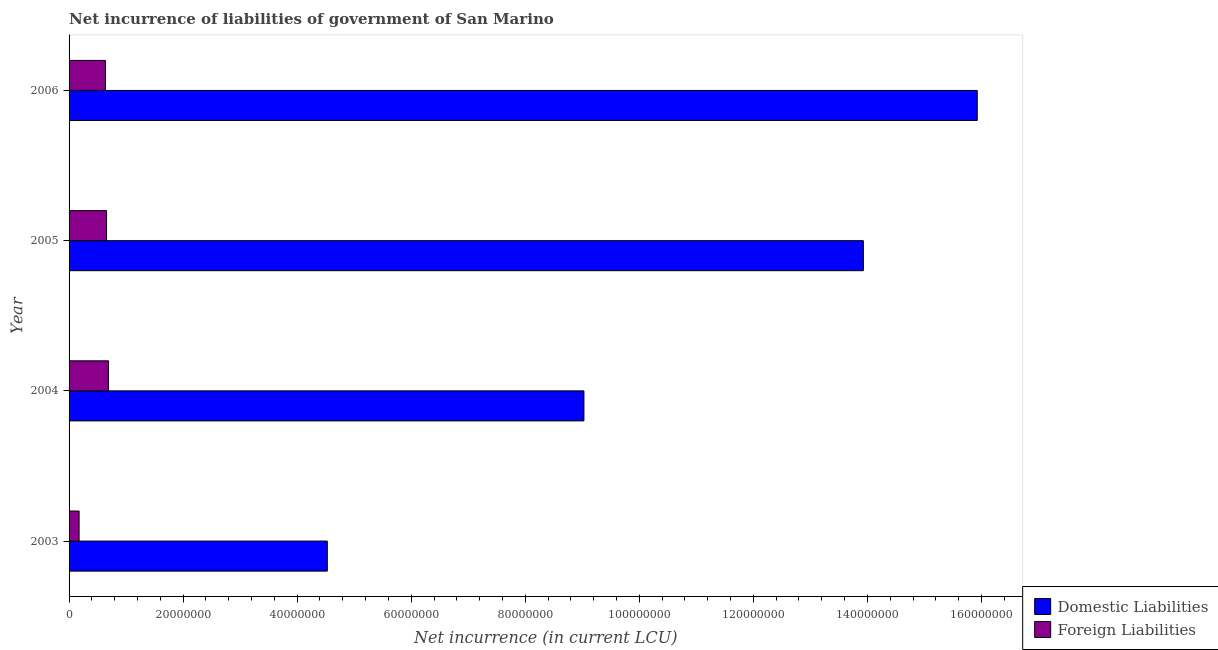Are the number of bars per tick equal to the number of legend labels?
Your answer should be compact. Yes. Are the number of bars on each tick of the Y-axis equal?
Keep it short and to the point. Yes. How many bars are there on the 4th tick from the top?
Offer a terse response. 2. How many bars are there on the 3rd tick from the bottom?
Your response must be concise. 2. In how many cases, is the number of bars for a given year not equal to the number of legend labels?
Keep it short and to the point. 0. What is the net incurrence of foreign liabilities in 2004?
Your answer should be very brief. 6.92e+06. Across all years, what is the maximum net incurrence of foreign liabilities?
Provide a succinct answer. 6.92e+06. Across all years, what is the minimum net incurrence of foreign liabilities?
Ensure brevity in your answer.  1.76e+06. What is the total net incurrence of domestic liabilities in the graph?
Your response must be concise. 4.34e+08. What is the difference between the net incurrence of foreign liabilities in 2005 and that in 2006?
Give a very brief answer. 2.02e+05. What is the difference between the net incurrence of foreign liabilities in 2004 and the net incurrence of domestic liabilities in 2003?
Your response must be concise. -3.84e+07. What is the average net incurrence of domestic liabilities per year?
Provide a succinct answer. 1.09e+08. In the year 2006, what is the difference between the net incurrence of foreign liabilities and net incurrence of domestic liabilities?
Make the answer very short. -1.53e+08. What is the ratio of the net incurrence of foreign liabilities in 2003 to that in 2005?
Keep it short and to the point. 0.27. Is the difference between the net incurrence of foreign liabilities in 2004 and 2006 greater than the difference between the net incurrence of domestic liabilities in 2004 and 2006?
Give a very brief answer. Yes. What is the difference between the highest and the second highest net incurrence of foreign liabilities?
Offer a terse response. 3.44e+05. What is the difference between the highest and the lowest net incurrence of domestic liabilities?
Your answer should be very brief. 1.14e+08. Is the sum of the net incurrence of foreign liabilities in 2004 and 2006 greater than the maximum net incurrence of domestic liabilities across all years?
Your answer should be compact. No. What does the 2nd bar from the top in 2005 represents?
Offer a terse response. Domestic Liabilities. What does the 1st bar from the bottom in 2003 represents?
Your response must be concise. Domestic Liabilities. What is the difference between two consecutive major ticks on the X-axis?
Provide a succinct answer. 2.00e+07. Does the graph contain any zero values?
Provide a short and direct response. No. Where does the legend appear in the graph?
Ensure brevity in your answer.  Bottom right. How many legend labels are there?
Your answer should be very brief. 2. How are the legend labels stacked?
Provide a short and direct response. Vertical. What is the title of the graph?
Your response must be concise. Net incurrence of liabilities of government of San Marino. Does "Time to import" appear as one of the legend labels in the graph?
Your answer should be very brief. No. What is the label or title of the X-axis?
Offer a terse response. Net incurrence (in current LCU). What is the label or title of the Y-axis?
Your answer should be compact. Year. What is the Net incurrence (in current LCU) of Domestic Liabilities in 2003?
Your answer should be very brief. 4.53e+07. What is the Net incurrence (in current LCU) of Foreign Liabilities in 2003?
Give a very brief answer. 1.76e+06. What is the Net incurrence (in current LCU) in Domestic Liabilities in 2004?
Provide a succinct answer. 9.03e+07. What is the Net incurrence (in current LCU) of Foreign Liabilities in 2004?
Offer a very short reply. 6.92e+06. What is the Net incurrence (in current LCU) of Domestic Liabilities in 2005?
Your answer should be very brief. 1.39e+08. What is the Net incurrence (in current LCU) in Foreign Liabilities in 2005?
Give a very brief answer. 6.57e+06. What is the Net incurrence (in current LCU) in Domestic Liabilities in 2006?
Offer a terse response. 1.59e+08. What is the Net incurrence (in current LCU) of Foreign Liabilities in 2006?
Your answer should be very brief. 6.37e+06. Across all years, what is the maximum Net incurrence (in current LCU) of Domestic Liabilities?
Ensure brevity in your answer.  1.59e+08. Across all years, what is the maximum Net incurrence (in current LCU) in Foreign Liabilities?
Provide a short and direct response. 6.92e+06. Across all years, what is the minimum Net incurrence (in current LCU) of Domestic Liabilities?
Offer a very short reply. 4.53e+07. Across all years, what is the minimum Net incurrence (in current LCU) of Foreign Liabilities?
Keep it short and to the point. 1.76e+06. What is the total Net incurrence (in current LCU) of Domestic Liabilities in the graph?
Give a very brief answer. 4.34e+08. What is the total Net incurrence (in current LCU) in Foreign Liabilities in the graph?
Provide a short and direct response. 2.16e+07. What is the difference between the Net incurrence (in current LCU) of Domestic Liabilities in 2003 and that in 2004?
Your response must be concise. -4.50e+07. What is the difference between the Net incurrence (in current LCU) in Foreign Liabilities in 2003 and that in 2004?
Offer a terse response. -5.16e+06. What is the difference between the Net incurrence (in current LCU) in Domestic Liabilities in 2003 and that in 2005?
Keep it short and to the point. -9.40e+07. What is the difference between the Net incurrence (in current LCU) in Foreign Liabilities in 2003 and that in 2005?
Your answer should be very brief. -4.82e+06. What is the difference between the Net incurrence (in current LCU) of Domestic Liabilities in 2003 and that in 2006?
Offer a very short reply. -1.14e+08. What is the difference between the Net incurrence (in current LCU) of Foreign Liabilities in 2003 and that in 2006?
Offer a terse response. -4.62e+06. What is the difference between the Net incurrence (in current LCU) of Domestic Liabilities in 2004 and that in 2005?
Provide a short and direct response. -4.90e+07. What is the difference between the Net incurrence (in current LCU) in Foreign Liabilities in 2004 and that in 2005?
Offer a very short reply. 3.44e+05. What is the difference between the Net incurrence (in current LCU) in Domestic Liabilities in 2004 and that in 2006?
Provide a short and direct response. -6.90e+07. What is the difference between the Net incurrence (in current LCU) of Foreign Liabilities in 2004 and that in 2006?
Your answer should be very brief. 5.46e+05. What is the difference between the Net incurrence (in current LCU) in Domestic Liabilities in 2005 and that in 2006?
Give a very brief answer. -2.00e+07. What is the difference between the Net incurrence (in current LCU) of Foreign Liabilities in 2005 and that in 2006?
Make the answer very short. 2.02e+05. What is the difference between the Net incurrence (in current LCU) of Domestic Liabilities in 2003 and the Net incurrence (in current LCU) of Foreign Liabilities in 2004?
Offer a terse response. 3.84e+07. What is the difference between the Net incurrence (in current LCU) in Domestic Liabilities in 2003 and the Net incurrence (in current LCU) in Foreign Liabilities in 2005?
Provide a short and direct response. 3.87e+07. What is the difference between the Net incurrence (in current LCU) of Domestic Liabilities in 2003 and the Net incurrence (in current LCU) of Foreign Liabilities in 2006?
Offer a terse response. 3.89e+07. What is the difference between the Net incurrence (in current LCU) of Domestic Liabilities in 2004 and the Net incurrence (in current LCU) of Foreign Liabilities in 2005?
Ensure brevity in your answer.  8.37e+07. What is the difference between the Net incurrence (in current LCU) in Domestic Liabilities in 2004 and the Net incurrence (in current LCU) in Foreign Liabilities in 2006?
Your answer should be compact. 8.39e+07. What is the difference between the Net incurrence (in current LCU) in Domestic Liabilities in 2005 and the Net incurrence (in current LCU) in Foreign Liabilities in 2006?
Your answer should be compact. 1.33e+08. What is the average Net incurrence (in current LCU) in Domestic Liabilities per year?
Provide a succinct answer. 1.09e+08. What is the average Net incurrence (in current LCU) in Foreign Liabilities per year?
Provide a succinct answer. 5.41e+06. In the year 2003, what is the difference between the Net incurrence (in current LCU) of Domestic Liabilities and Net incurrence (in current LCU) of Foreign Liabilities?
Ensure brevity in your answer.  4.35e+07. In the year 2004, what is the difference between the Net incurrence (in current LCU) in Domestic Liabilities and Net incurrence (in current LCU) in Foreign Liabilities?
Ensure brevity in your answer.  8.34e+07. In the year 2005, what is the difference between the Net incurrence (in current LCU) in Domestic Liabilities and Net incurrence (in current LCU) in Foreign Liabilities?
Your response must be concise. 1.33e+08. In the year 2006, what is the difference between the Net incurrence (in current LCU) in Domestic Liabilities and Net incurrence (in current LCU) in Foreign Liabilities?
Provide a succinct answer. 1.53e+08. What is the ratio of the Net incurrence (in current LCU) of Domestic Liabilities in 2003 to that in 2004?
Give a very brief answer. 0.5. What is the ratio of the Net incurrence (in current LCU) of Foreign Liabilities in 2003 to that in 2004?
Keep it short and to the point. 0.25. What is the ratio of the Net incurrence (in current LCU) of Domestic Liabilities in 2003 to that in 2005?
Your answer should be very brief. 0.33. What is the ratio of the Net incurrence (in current LCU) in Foreign Liabilities in 2003 to that in 2005?
Your answer should be compact. 0.27. What is the ratio of the Net incurrence (in current LCU) of Domestic Liabilities in 2003 to that in 2006?
Offer a very short reply. 0.28. What is the ratio of the Net incurrence (in current LCU) in Foreign Liabilities in 2003 to that in 2006?
Ensure brevity in your answer.  0.28. What is the ratio of the Net incurrence (in current LCU) in Domestic Liabilities in 2004 to that in 2005?
Your answer should be compact. 0.65. What is the ratio of the Net incurrence (in current LCU) in Foreign Liabilities in 2004 to that in 2005?
Provide a short and direct response. 1.05. What is the ratio of the Net incurrence (in current LCU) of Domestic Liabilities in 2004 to that in 2006?
Offer a terse response. 0.57. What is the ratio of the Net incurrence (in current LCU) in Foreign Liabilities in 2004 to that in 2006?
Provide a short and direct response. 1.09. What is the ratio of the Net incurrence (in current LCU) in Domestic Liabilities in 2005 to that in 2006?
Ensure brevity in your answer.  0.87. What is the ratio of the Net incurrence (in current LCU) of Foreign Liabilities in 2005 to that in 2006?
Your response must be concise. 1.03. What is the difference between the highest and the second highest Net incurrence (in current LCU) in Domestic Liabilities?
Make the answer very short. 2.00e+07. What is the difference between the highest and the second highest Net incurrence (in current LCU) of Foreign Liabilities?
Provide a short and direct response. 3.44e+05. What is the difference between the highest and the lowest Net incurrence (in current LCU) of Domestic Liabilities?
Keep it short and to the point. 1.14e+08. What is the difference between the highest and the lowest Net incurrence (in current LCU) of Foreign Liabilities?
Offer a terse response. 5.16e+06. 